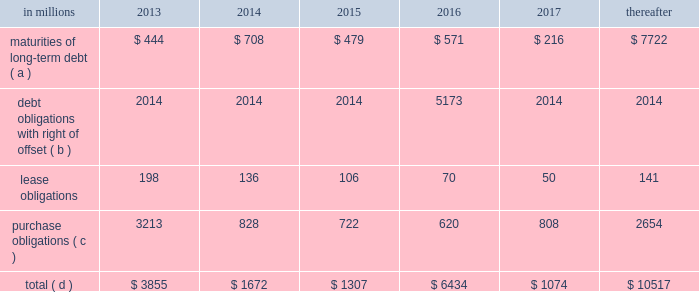Through current cash balances and cash from oper- ations .
Additionally , the company has existing credit facilities totaling $ 2.5 billion .
The company was in compliance with all its debt covenants at december 31 , 2012 .
The company 2019s financial covenants require the maintenance of a minimum net worth of $ 9 billion and a total debt-to- capital ratio of less than 60% ( 60 % ) .
Net worth is defined as the sum of common stock , paid-in capital and retained earnings , less treasury stock plus any cumulative goodwill impairment charges .
The calcu- lation also excludes accumulated other compre- hensive income/loss and nonrecourse financial liabilities of special purpose entities .
The total debt- to-capital ratio is defined as total debt divided by the sum of total debt plus net worth .
At december 31 , 2012 , international paper 2019s net worth was $ 13.9 bil- lion , and the total-debt-to-capital ratio was 42% ( 42 % ) .
The company will continue to rely upon debt and capital markets for the majority of any necessary long-term funding not provided by operating cash flows .
Funding decisions will be guided by our capi- tal structure planning objectives .
The primary goals of the company 2019s capital structure planning are to maximize financial flexibility and preserve liquidity while reducing interest expense .
The majority of international paper 2019s debt is accessed through global public capital markets where we have a wide base of investors .
Maintaining an investment grade credit rating is an important element of international paper 2019s financing strategy .
At december 31 , 2012 , the company held long-term credit ratings of bbb ( stable outlook ) and baa3 ( stable outlook ) by s&p and moody 2019s , respectively .
Contractual obligations for future payments under existing debt and lease commitments and purchase obligations at december 31 , 2012 , were as follows: .
( a ) total debt includes scheduled principal payments only .
( b ) represents debt obligations borrowed from non-consolidated variable interest entities for which international paper has , and intends to effect , a legal right to offset these obligations with investments held in the entities .
Accordingly , in its con- solidated balance sheet at december 31 , 2012 , international paper has offset approximately $ 5.2 billion of interests in the entities against this $ 5.2 billion of debt obligations held by the entities ( see note 11 variable interest entities and preferred securities of subsidiaries on pages 69 through 72 in item 8 .
Financial statements and supplementary data ) .
( c ) includes $ 3.6 billion relating to fiber supply agreements entered into at the time of the 2006 transformation plan forest- land sales and in conjunction with the 2008 acquisition of weyerhaeuser company 2019s containerboard , packaging and recycling business .
( d ) not included in the above table due to the uncertainty as to the amount and timing of the payment are unrecognized tax bene- fits of approximately $ 620 million .
We consider the undistributed earnings of our for- eign subsidiaries as of december 31 , 2012 , to be indefinitely reinvested and , accordingly , no u.s .
Income taxes have been provided thereon .
As of december 31 , 2012 , the amount of cash associated with indefinitely reinvested foreign earnings was approximately $ 840 million .
We do not anticipate the need to repatriate funds to the united states to sat- isfy domestic liquidity needs arising in the ordinary course of business , including liquidity needs asso- ciated with our domestic debt service requirements .
Pension obligations and funding at december 31 , 2012 , the projected benefit obliga- tion for the company 2019s u.s .
Defined benefit plans determined under u.s .
Gaap was approximately $ 4.1 billion higher than the fair value of plan assets .
Approximately $ 3.7 billion of this amount relates to plans that are subject to minimum funding require- ments .
Under current irs funding rules , the calcu- lation of minimum funding requirements differs from the calculation of the present value of plan benefits ( the projected benefit obligation ) for accounting purposes .
In december 2008 , the worker , retiree and employer recovery act of 2008 ( wera ) was passed by the u.s .
Congress which provided for pension funding relief and technical corrections .
Funding contributions depend on the funding method selected by the company , and the timing of its implementation , as well as on actual demo- graphic data and the targeted funding level .
The company continually reassesses the amount and timing of any discretionary contributions and elected to make voluntary contributions totaling $ 44 million and $ 300 million for the years ended december 31 , 2012 and 2011 , respectively .
At this time , we expect that required contributions to its plans in 2013 will be approximately $ 31 million , although the company may elect to make future voluntary contributions .
The timing and amount of future contributions , which could be material , will depend on a number of factors , including the actual earnings and changes in values of plan assets and changes in interest rates .
Ilim holding s.a .
Shareholder 2019s agreement in october 2007 , in connection with the for- mation of the ilim holding s.a .
Joint venture , international paper entered into a share- holder 2019s agreement that includes provisions relating to the reconciliation of disputes among the partners .
This agreement provides that at .
What was the ratio of the company discretionary contributions a to the retirement plan for 2012 compared to 2011? 
Computations: (44 / 300)
Answer: 0.14667. 